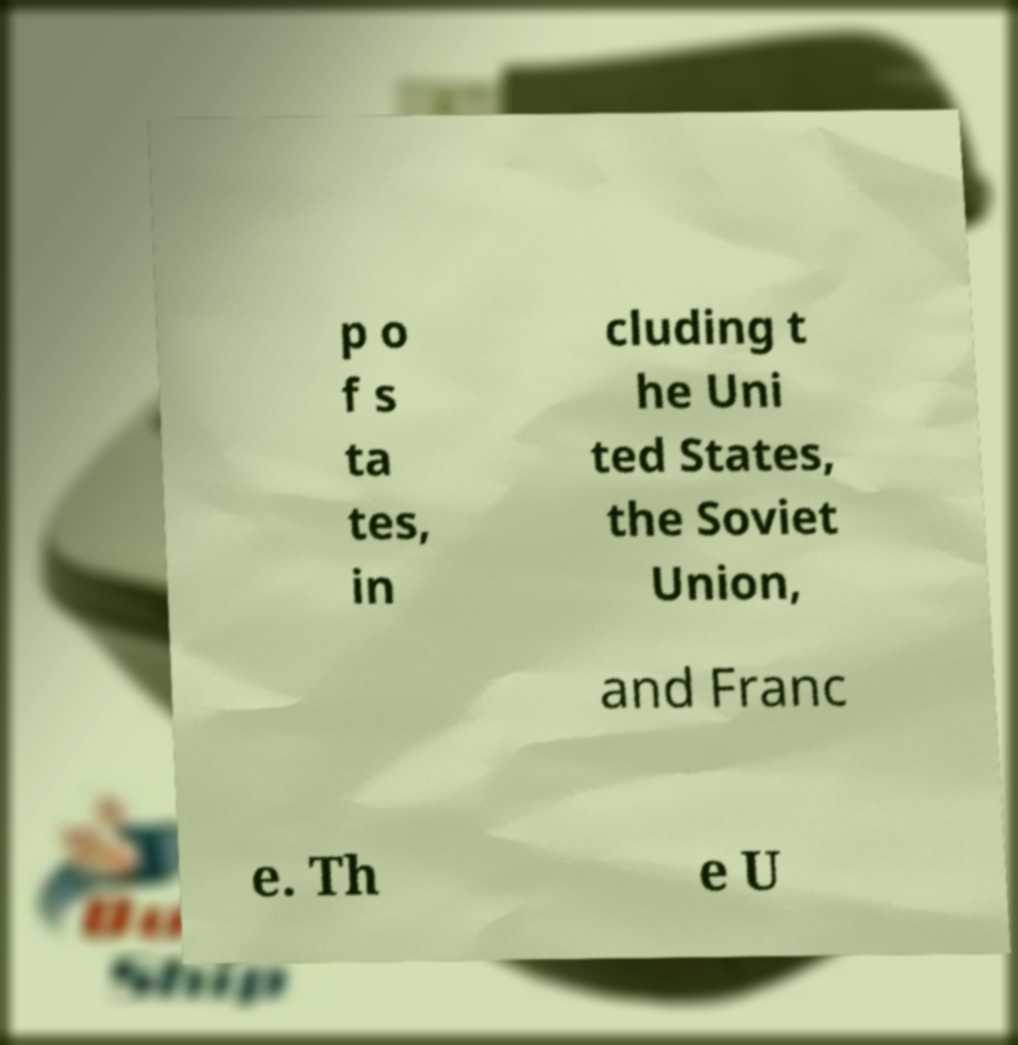Can you accurately transcribe the text from the provided image for me? p o f s ta tes, in cluding t he Uni ted States, the Soviet Union, and Franc e. Th e U 